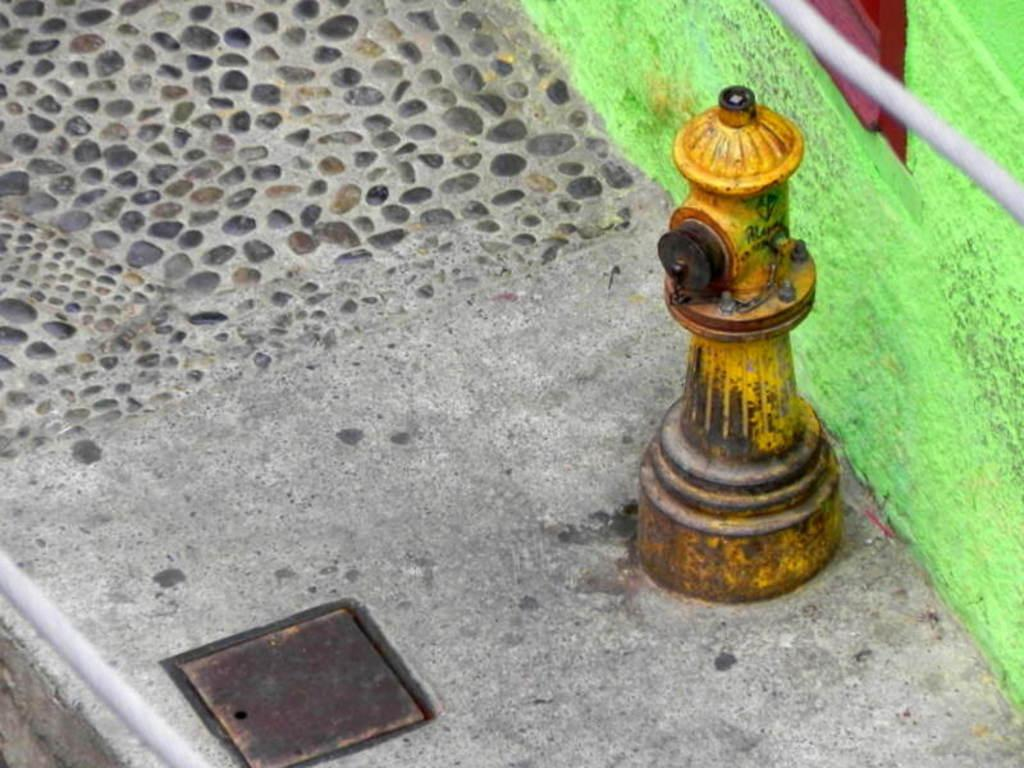What object is the main subject of the image? There is a fire hydrant in the image. Where is the fire hydrant located? The fire hydrant is on a pavement. What other structure is visible in the image? There is a wall in the image. How is the wall positioned in relation to the fire hydrant? The wall is beside the fire hydrant. What type of scale can be seen on the fire hydrant in the image? There is no scale present on the fire hydrant in the image. What color is the light emitted by the fire hydrant in the image? Fire hydrants do not emit light, so there is no light to describe in the image. 